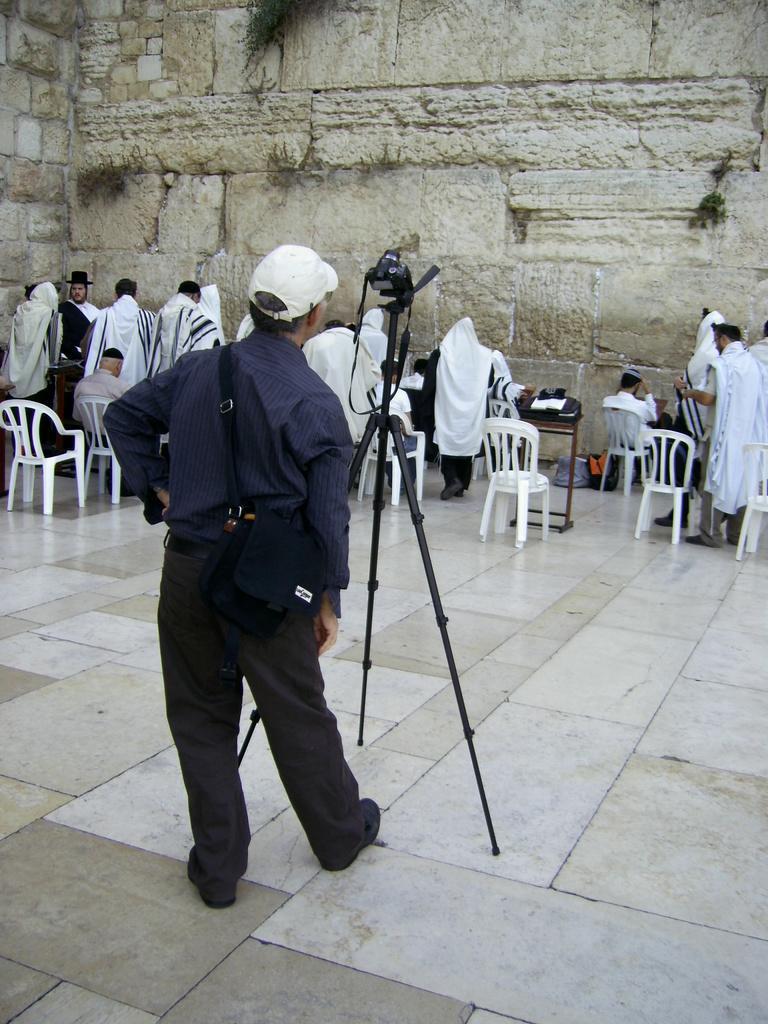Can you describe this image briefly? This picture describes about group of people few are seated on the chair and few are standing in the middle of the given image A man is standing in front of the camera, and we can see a wall. 